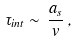Convert formula to latex. <formula><loc_0><loc_0><loc_500><loc_500>\tau _ { i n t } \sim \, \frac { a _ { s } } { v } \, ,</formula> 